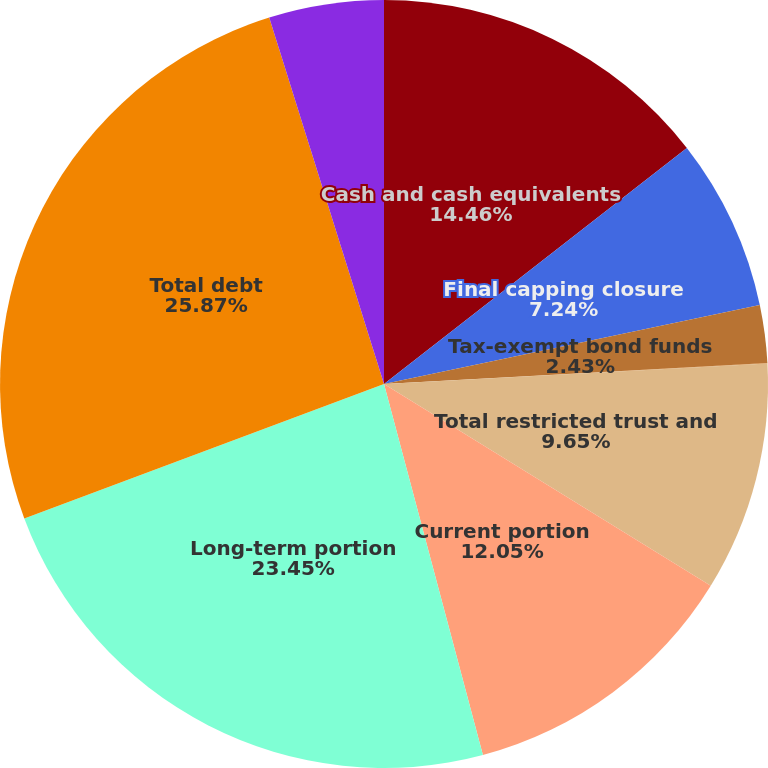<chart> <loc_0><loc_0><loc_500><loc_500><pie_chart><fcel>Cash and cash equivalents<fcel>Final capping closure<fcel>Tax-exempt bond funds<fcel>Other<fcel>Total restricted trust and<fcel>Current portion<fcel>Long-term portion<fcel>Total debt<fcel>Increase in carrying value of<nl><fcel>14.46%<fcel>7.24%<fcel>2.43%<fcel>0.02%<fcel>9.65%<fcel>12.05%<fcel>23.45%<fcel>25.86%<fcel>4.83%<nl></chart> 